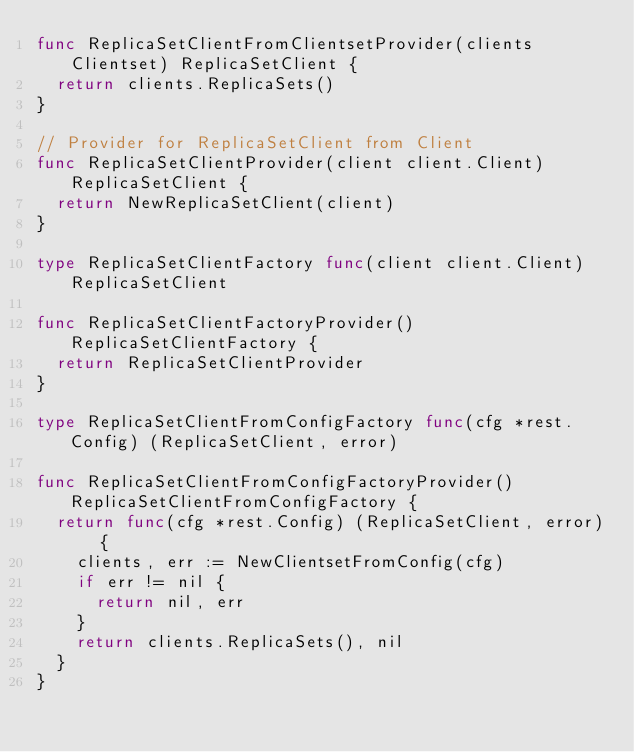Convert code to text. <code><loc_0><loc_0><loc_500><loc_500><_Go_>func ReplicaSetClientFromClientsetProvider(clients Clientset) ReplicaSetClient {
	return clients.ReplicaSets()
}

// Provider for ReplicaSetClient from Client
func ReplicaSetClientProvider(client client.Client) ReplicaSetClient {
	return NewReplicaSetClient(client)
}

type ReplicaSetClientFactory func(client client.Client) ReplicaSetClient

func ReplicaSetClientFactoryProvider() ReplicaSetClientFactory {
	return ReplicaSetClientProvider
}

type ReplicaSetClientFromConfigFactory func(cfg *rest.Config) (ReplicaSetClient, error)

func ReplicaSetClientFromConfigFactoryProvider() ReplicaSetClientFromConfigFactory {
	return func(cfg *rest.Config) (ReplicaSetClient, error) {
		clients, err := NewClientsetFromConfig(cfg)
		if err != nil {
			return nil, err
		}
		return clients.ReplicaSets(), nil
	}
}
</code> 